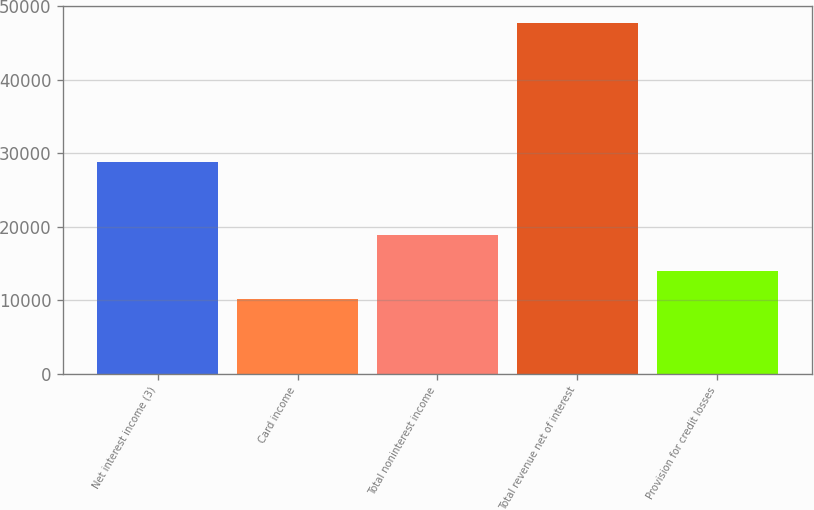<chart> <loc_0><loc_0><loc_500><loc_500><bar_chart><fcel>Net interest income (3)<fcel>Card income<fcel>Total noninterest income<fcel>Total revenue net of interest<fcel>Provision for credit losses<nl><fcel>28809<fcel>10189<fcel>18873<fcel>47682<fcel>13938.3<nl></chart> 